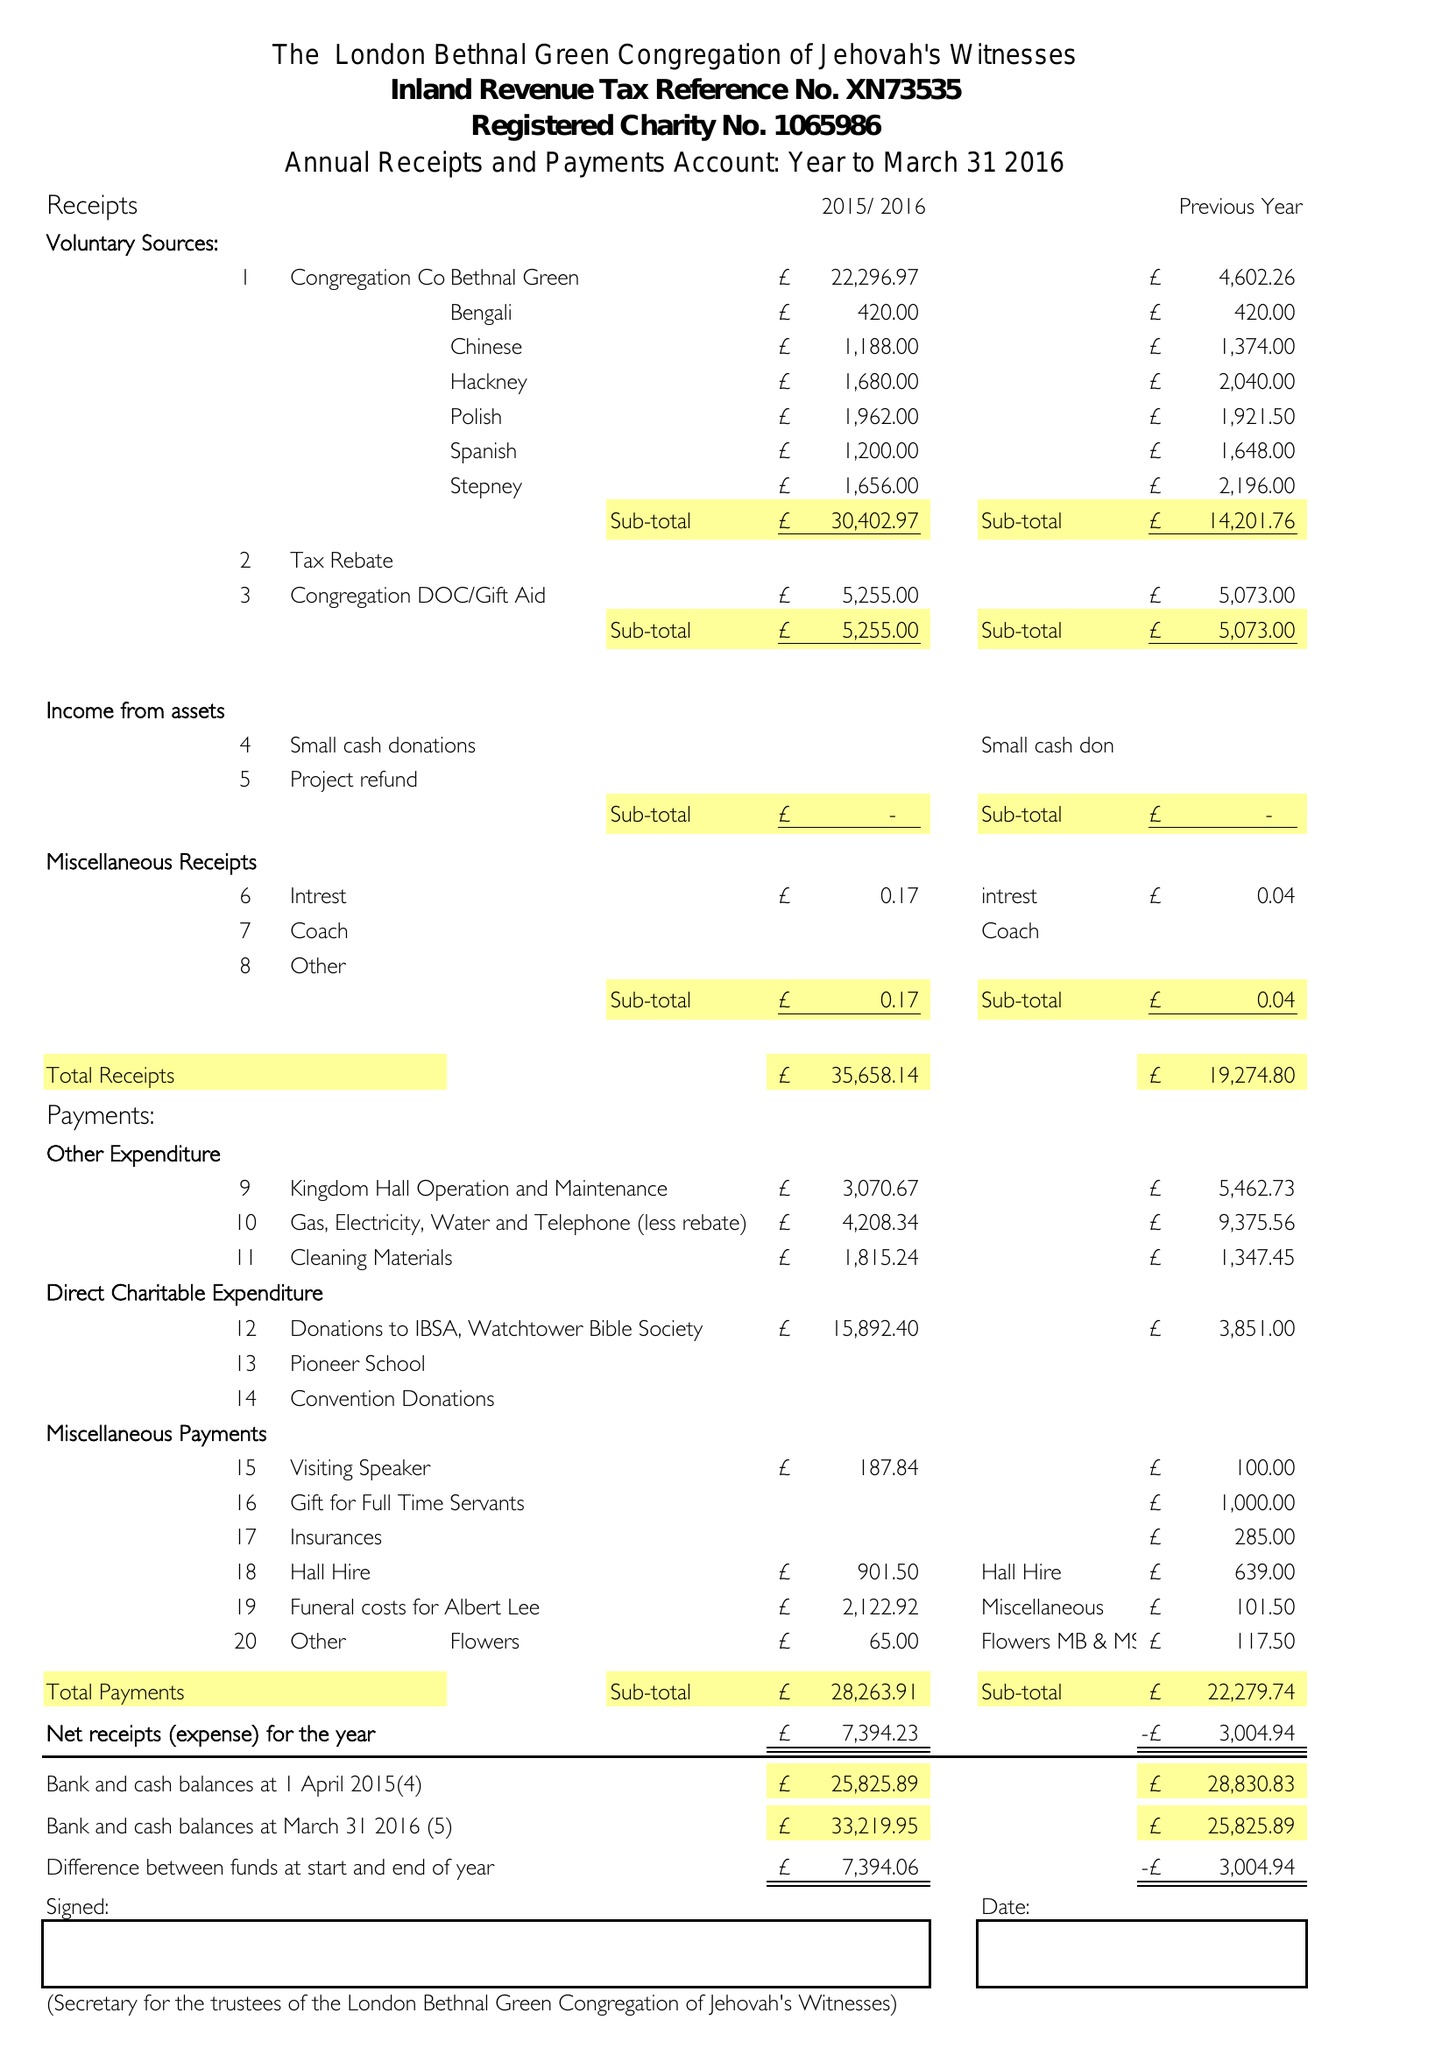What is the value for the address__street_line?
Answer the question using a single word or phrase. 184 GROVE ROAD 